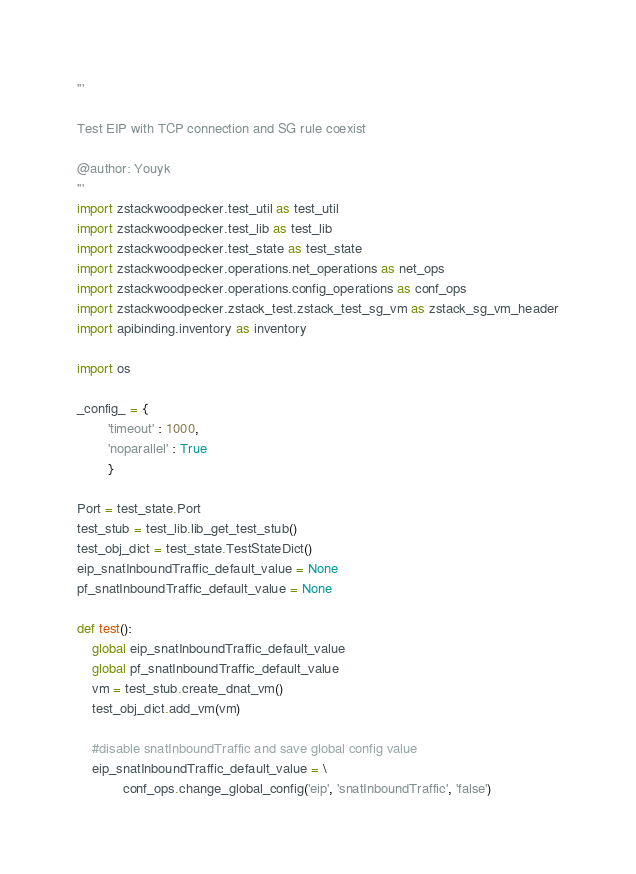<code> <loc_0><loc_0><loc_500><loc_500><_Python_>'''

Test EIP with TCP connection and SG rule coexist

@author: Youyk
'''
import zstackwoodpecker.test_util as test_util
import zstackwoodpecker.test_lib as test_lib
import zstackwoodpecker.test_state as test_state
import zstackwoodpecker.operations.net_operations as net_ops
import zstackwoodpecker.operations.config_operations as conf_ops
import zstackwoodpecker.zstack_test.zstack_test_sg_vm as zstack_sg_vm_header
import apibinding.inventory as inventory

import os

_config_ = {
        'timeout' : 1000,
        'noparallel' : True
        }

Port = test_state.Port
test_stub = test_lib.lib_get_test_stub()
test_obj_dict = test_state.TestStateDict()
eip_snatInboundTraffic_default_value = None
pf_snatInboundTraffic_default_value = None

def test():
    global eip_snatInboundTraffic_default_value
    global pf_snatInboundTraffic_default_value
    vm = test_stub.create_dnat_vm()
    test_obj_dict.add_vm(vm)

    #disable snatInboundTraffic and save global config value
    eip_snatInboundTraffic_default_value = \
            conf_ops.change_global_config('eip', 'snatInboundTraffic', 'false')</code> 